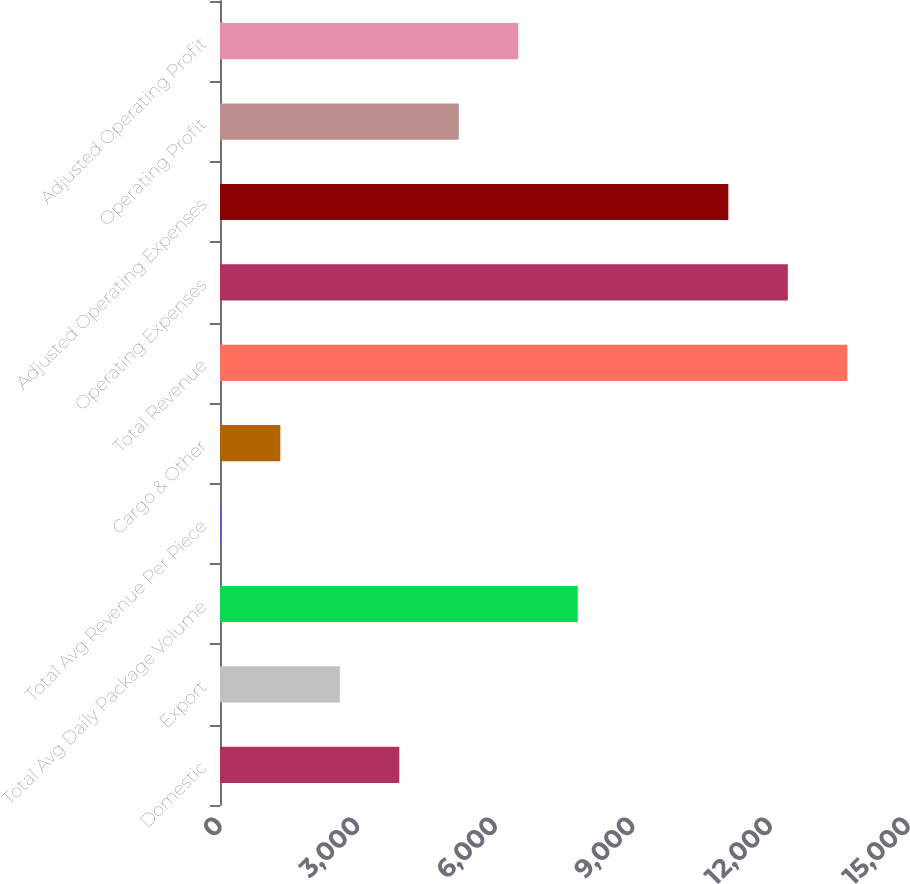<chart> <loc_0><loc_0><loc_500><loc_500><bar_chart><fcel>Domestic<fcel>Export<fcel>Total Avg Daily Package Volume<fcel>Total Avg Revenue Per Piece<fcel>Cargo & Other<fcel>Total Revenue<fcel>Operating Expenses<fcel>Adjusted Operating Expenses<fcel>Operating Profit<fcel>Adjusted Operating Profit<nl><fcel>3909.11<fcel>2612.12<fcel>7800.08<fcel>18.15<fcel>1315.14<fcel>13677<fcel>12380<fcel>11083<fcel>5206.1<fcel>6503.09<nl></chart> 